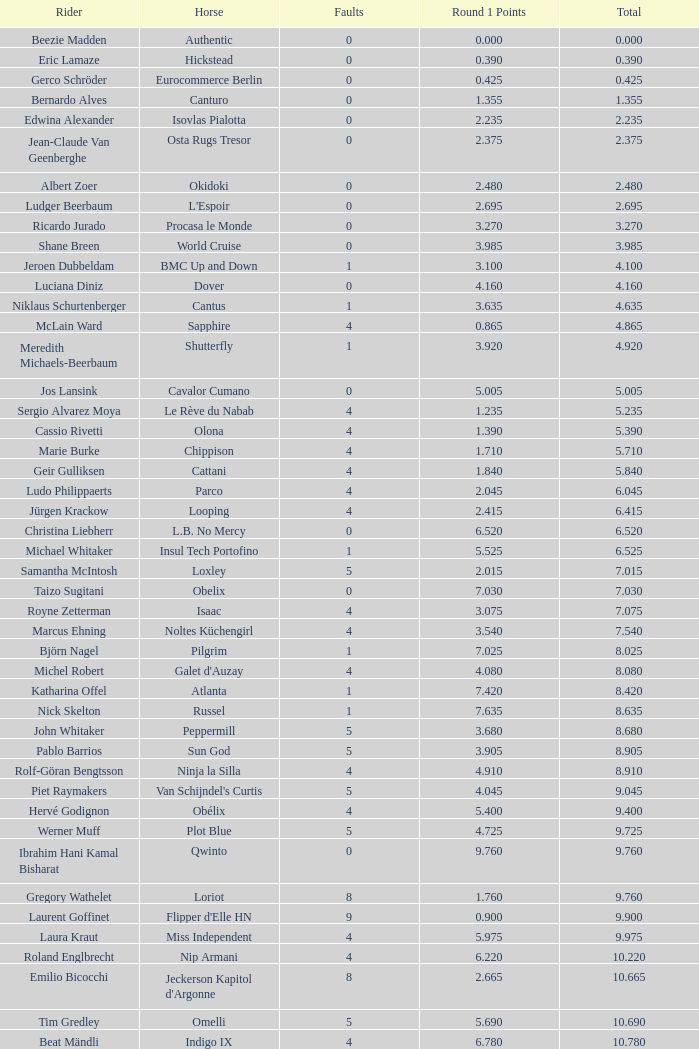Who is the rider scoring 1 Veronika Macanova. 